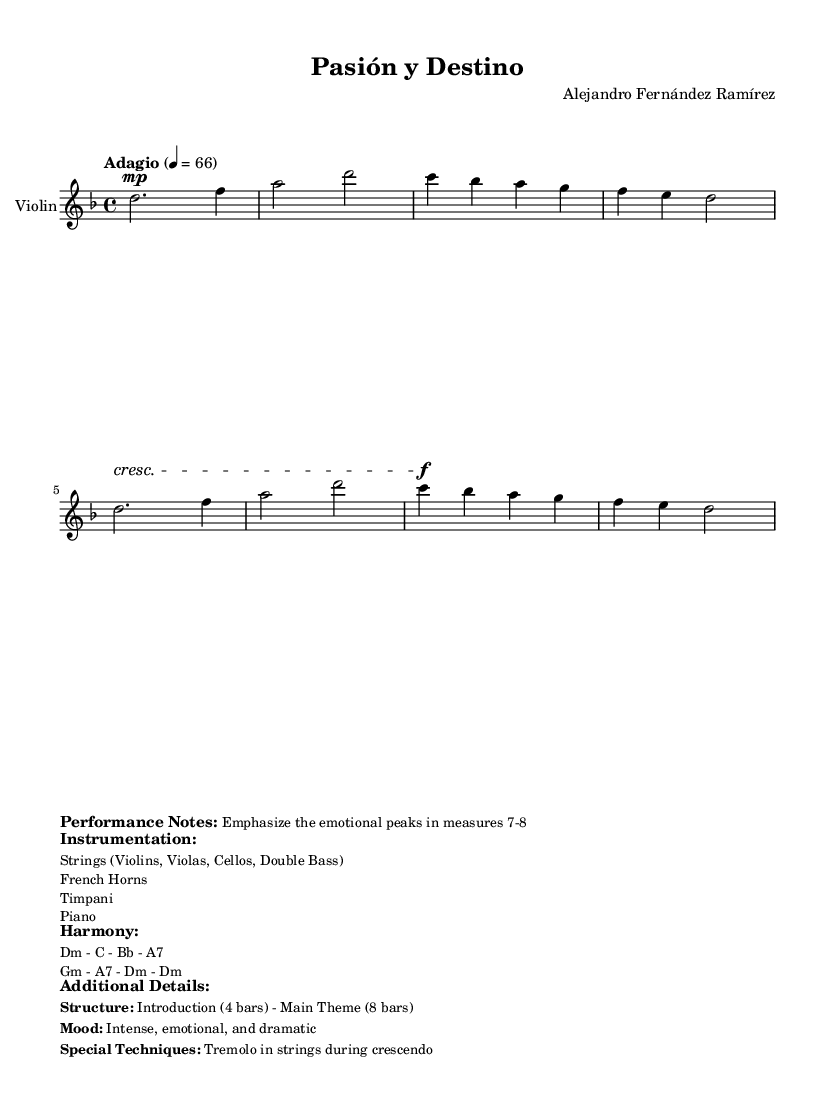What is the key signature of this music? The key signature is D minor, which is indicated by one flat (B flat).
Answer: D minor What is the time signature of the piece? The time signature is 4/4, which indicates four beats per measure.
Answer: 4/4 What is the indicated tempo for this composition? The tempo is indicated as "Adagio" with a speed of 66 beats per minute.
Answer: Adagio, 66 Identify the primary mood conveyed by this piece. The mood is described as "intense, emotional, and dramatic," implying a serious, passionate tone.
Answer: Intense, emotional, and dramatic What special technique is suggested during the crescendo? The score suggests a "tremolo in strings," which adds to the intensity and urgency of the passage.
Answer: Tremolo How many bars are there in the Introduction section? The introduction consists of 4 bars, as stated in the structure of the piece.
Answer: 4 bars What instrumentation is featured in this orchestral theme? The instrumentation includes "Strings (Violins, Violas, Cellos, Double Bass), French Horns, Timpani, and Piano," all contributing to the dramatic sound.
Answer: Strings, French Horns, Timpani, Piano 